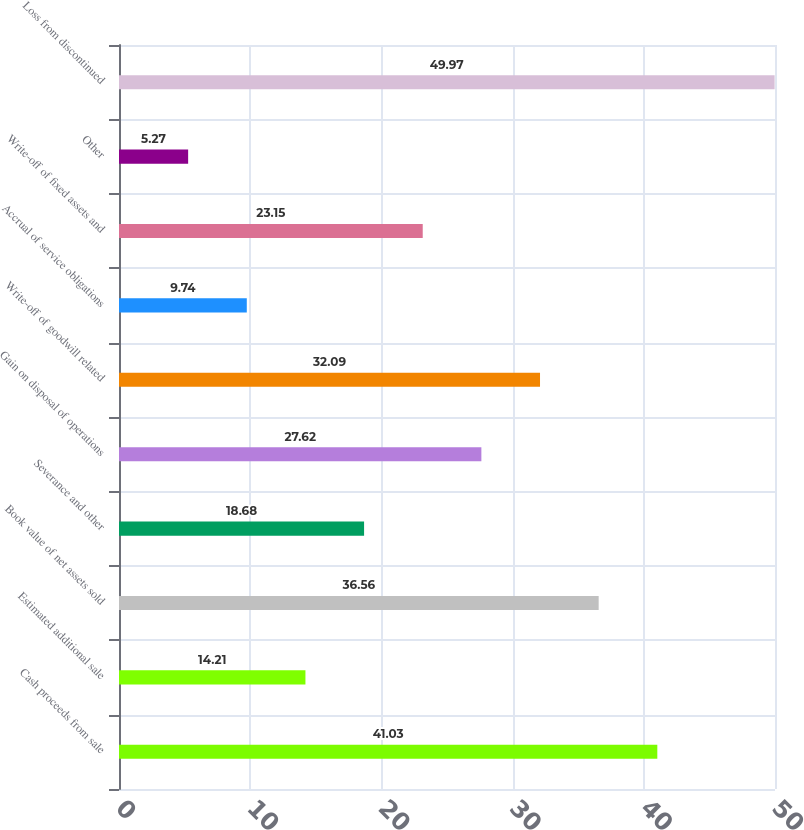Convert chart. <chart><loc_0><loc_0><loc_500><loc_500><bar_chart><fcel>Cash proceeds from sale<fcel>Estimated additional sale<fcel>Book value of net assets sold<fcel>Severance and other<fcel>Gain on disposal of operations<fcel>Write-off of goodwill related<fcel>Accrual of service obligations<fcel>Write-off of fixed assets and<fcel>Other<fcel>Loss from discontinued<nl><fcel>41.03<fcel>14.21<fcel>36.56<fcel>18.68<fcel>27.62<fcel>32.09<fcel>9.74<fcel>23.15<fcel>5.27<fcel>49.97<nl></chart> 